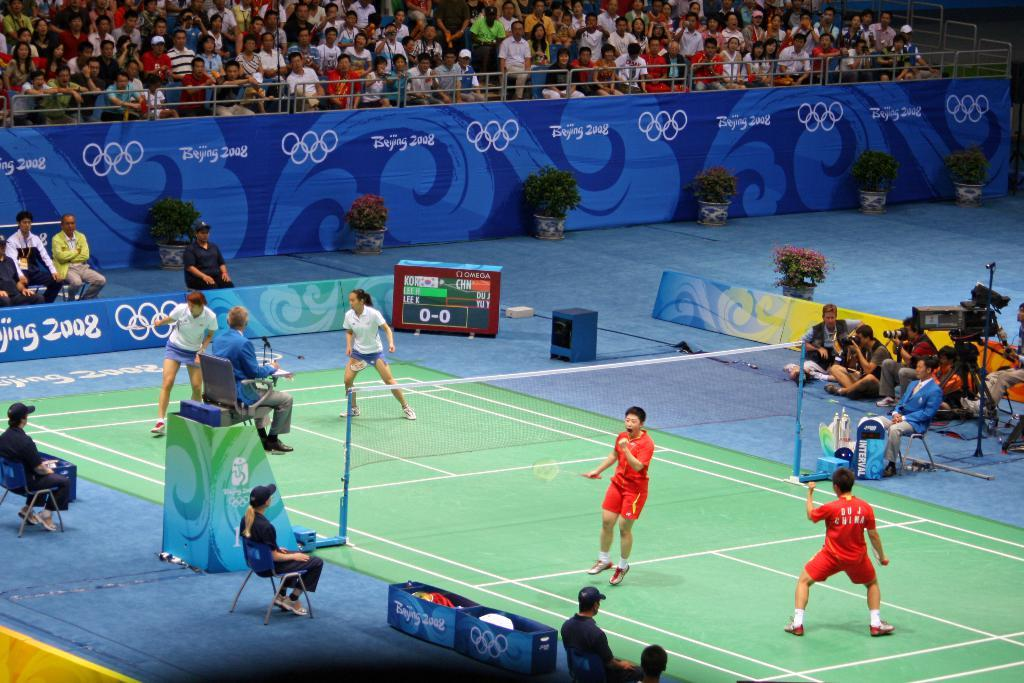<image>
Write a terse but informative summary of the picture. Players play volleyball at the Beijing 2008 olympics. 